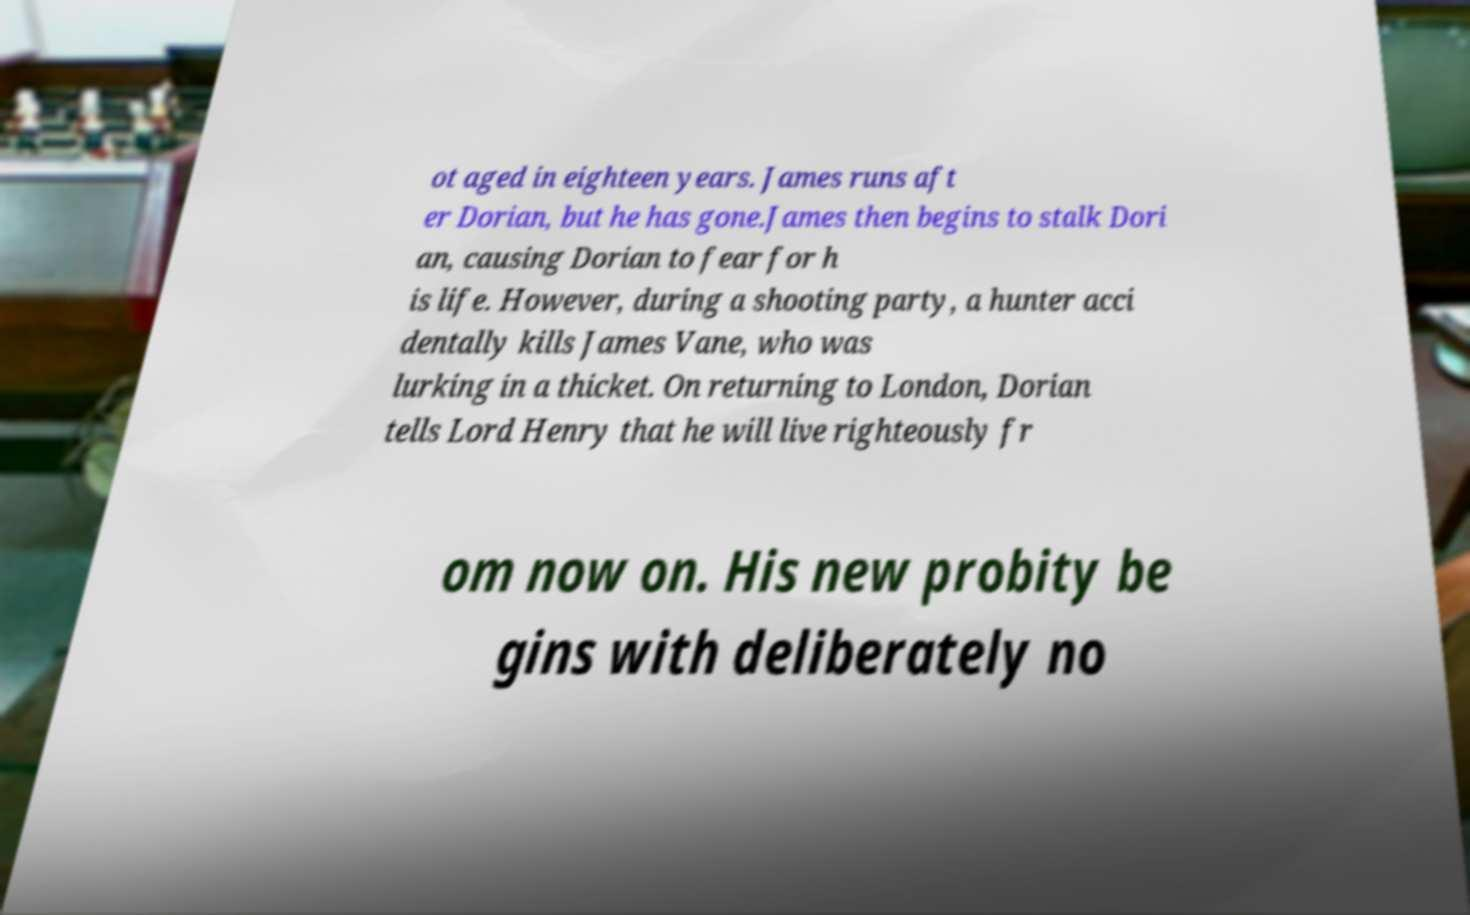Could you assist in decoding the text presented in this image and type it out clearly? ot aged in eighteen years. James runs aft er Dorian, but he has gone.James then begins to stalk Dori an, causing Dorian to fear for h is life. However, during a shooting party, a hunter acci dentally kills James Vane, who was lurking in a thicket. On returning to London, Dorian tells Lord Henry that he will live righteously fr om now on. His new probity be gins with deliberately no 